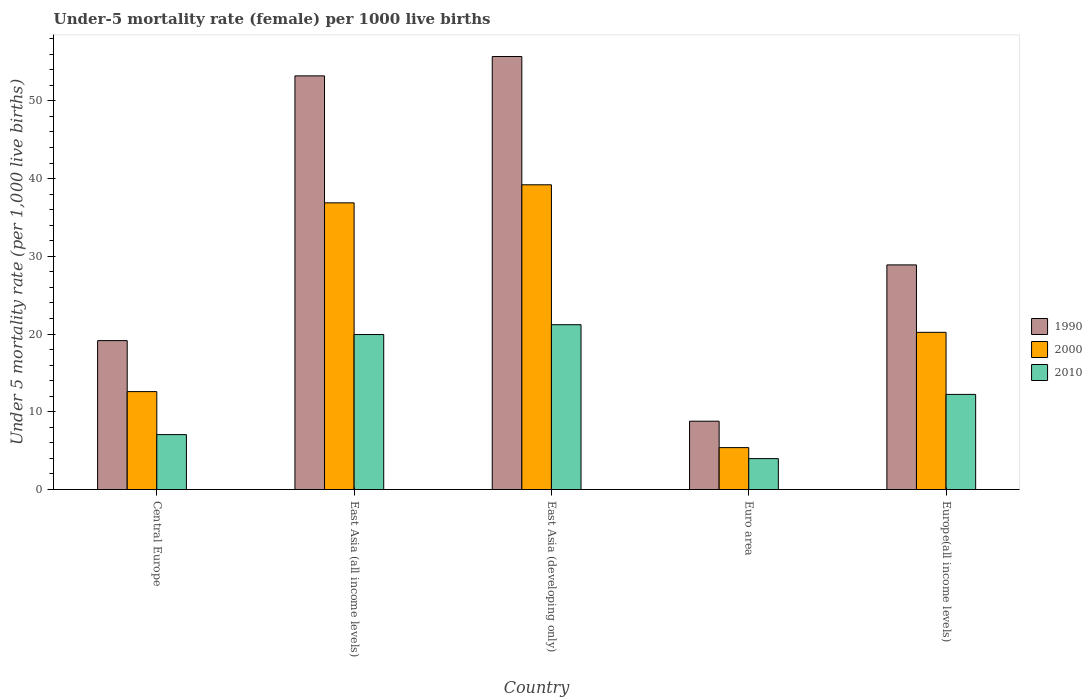How many different coloured bars are there?
Offer a very short reply. 3. Are the number of bars per tick equal to the number of legend labels?
Your answer should be compact. Yes. How many bars are there on the 1st tick from the left?
Give a very brief answer. 3. What is the label of the 5th group of bars from the left?
Provide a succinct answer. Europe(all income levels). What is the under-five mortality rate in 1990 in East Asia (all income levels)?
Your response must be concise. 53.21. Across all countries, what is the maximum under-five mortality rate in 1990?
Your answer should be very brief. 55.7. Across all countries, what is the minimum under-five mortality rate in 2010?
Your answer should be compact. 3.97. In which country was the under-five mortality rate in 1990 maximum?
Your answer should be compact. East Asia (developing only). What is the total under-five mortality rate in 1990 in the graph?
Your response must be concise. 165.75. What is the difference between the under-five mortality rate in 2000 in Euro area and that in Europe(all income levels)?
Offer a terse response. -14.83. What is the difference between the under-five mortality rate in 2000 in East Asia (all income levels) and the under-five mortality rate in 1990 in Central Europe?
Your answer should be compact. 17.73. What is the average under-five mortality rate in 2000 per country?
Your response must be concise. 22.86. What is the difference between the under-five mortality rate of/in 2010 and under-five mortality rate of/in 2000 in East Asia (all income levels)?
Make the answer very short. -16.94. In how many countries, is the under-five mortality rate in 2000 greater than 32?
Make the answer very short. 2. What is the ratio of the under-five mortality rate in 1990 in Central Europe to that in East Asia (developing only)?
Provide a short and direct response. 0.34. Is the under-five mortality rate in 1990 in East Asia (all income levels) less than that in East Asia (developing only)?
Provide a short and direct response. Yes. Is the difference between the under-five mortality rate in 2010 in Central Europe and East Asia (developing only) greater than the difference between the under-five mortality rate in 2000 in Central Europe and East Asia (developing only)?
Keep it short and to the point. Yes. What is the difference between the highest and the second highest under-five mortality rate in 1990?
Ensure brevity in your answer.  -24.32. What is the difference between the highest and the lowest under-five mortality rate in 2010?
Keep it short and to the point. 17.23. In how many countries, is the under-five mortality rate in 2010 greater than the average under-five mortality rate in 2010 taken over all countries?
Make the answer very short. 2. Is it the case that in every country, the sum of the under-five mortality rate in 2000 and under-five mortality rate in 1990 is greater than the under-five mortality rate in 2010?
Ensure brevity in your answer.  Yes. How many countries are there in the graph?
Ensure brevity in your answer.  5. What is the difference between two consecutive major ticks on the Y-axis?
Provide a short and direct response. 10. Are the values on the major ticks of Y-axis written in scientific E-notation?
Offer a very short reply. No. Does the graph contain grids?
Keep it short and to the point. No. Where does the legend appear in the graph?
Ensure brevity in your answer.  Center right. How are the legend labels stacked?
Keep it short and to the point. Vertical. What is the title of the graph?
Make the answer very short. Under-5 mortality rate (female) per 1000 live births. What is the label or title of the Y-axis?
Provide a succinct answer. Under 5 mortality rate (per 1,0 live births). What is the Under 5 mortality rate (per 1,000 live births) of 1990 in Central Europe?
Your answer should be compact. 19.15. What is the Under 5 mortality rate (per 1,000 live births) of 2000 in Central Europe?
Offer a terse response. 12.6. What is the Under 5 mortality rate (per 1,000 live births) in 2010 in Central Europe?
Offer a very short reply. 7.06. What is the Under 5 mortality rate (per 1,000 live births) of 1990 in East Asia (all income levels)?
Offer a very short reply. 53.21. What is the Under 5 mortality rate (per 1,000 live births) in 2000 in East Asia (all income levels)?
Offer a very short reply. 36.88. What is the Under 5 mortality rate (per 1,000 live births) of 2010 in East Asia (all income levels)?
Keep it short and to the point. 19.94. What is the Under 5 mortality rate (per 1,000 live births) of 1990 in East Asia (developing only)?
Keep it short and to the point. 55.7. What is the Under 5 mortality rate (per 1,000 live births) of 2000 in East Asia (developing only)?
Keep it short and to the point. 39.2. What is the Under 5 mortality rate (per 1,000 live births) of 2010 in East Asia (developing only)?
Give a very brief answer. 21.2. What is the Under 5 mortality rate (per 1,000 live births) of 1990 in Euro area?
Ensure brevity in your answer.  8.79. What is the Under 5 mortality rate (per 1,000 live births) in 2000 in Euro area?
Offer a very short reply. 5.39. What is the Under 5 mortality rate (per 1,000 live births) in 2010 in Euro area?
Offer a terse response. 3.97. What is the Under 5 mortality rate (per 1,000 live births) of 1990 in Europe(all income levels)?
Provide a succinct answer. 28.9. What is the Under 5 mortality rate (per 1,000 live births) of 2000 in Europe(all income levels)?
Provide a short and direct response. 20.22. What is the Under 5 mortality rate (per 1,000 live births) in 2010 in Europe(all income levels)?
Keep it short and to the point. 12.24. Across all countries, what is the maximum Under 5 mortality rate (per 1,000 live births) of 1990?
Provide a succinct answer. 55.7. Across all countries, what is the maximum Under 5 mortality rate (per 1,000 live births) of 2000?
Provide a succinct answer. 39.2. Across all countries, what is the maximum Under 5 mortality rate (per 1,000 live births) in 2010?
Provide a short and direct response. 21.2. Across all countries, what is the minimum Under 5 mortality rate (per 1,000 live births) in 1990?
Make the answer very short. 8.79. Across all countries, what is the minimum Under 5 mortality rate (per 1,000 live births) of 2000?
Give a very brief answer. 5.39. Across all countries, what is the minimum Under 5 mortality rate (per 1,000 live births) in 2010?
Keep it short and to the point. 3.97. What is the total Under 5 mortality rate (per 1,000 live births) of 1990 in the graph?
Offer a terse response. 165.75. What is the total Under 5 mortality rate (per 1,000 live births) in 2000 in the graph?
Offer a terse response. 114.29. What is the total Under 5 mortality rate (per 1,000 live births) in 2010 in the graph?
Ensure brevity in your answer.  64.41. What is the difference between the Under 5 mortality rate (per 1,000 live births) of 1990 in Central Europe and that in East Asia (all income levels)?
Your response must be concise. -34.06. What is the difference between the Under 5 mortality rate (per 1,000 live births) in 2000 in Central Europe and that in East Asia (all income levels)?
Offer a terse response. -24.28. What is the difference between the Under 5 mortality rate (per 1,000 live births) in 2010 in Central Europe and that in East Asia (all income levels)?
Your response must be concise. -12.87. What is the difference between the Under 5 mortality rate (per 1,000 live births) of 1990 in Central Europe and that in East Asia (developing only)?
Provide a short and direct response. -36.55. What is the difference between the Under 5 mortality rate (per 1,000 live births) of 2000 in Central Europe and that in East Asia (developing only)?
Your response must be concise. -26.6. What is the difference between the Under 5 mortality rate (per 1,000 live births) of 2010 in Central Europe and that in East Asia (developing only)?
Provide a short and direct response. -14.14. What is the difference between the Under 5 mortality rate (per 1,000 live births) in 1990 in Central Europe and that in Euro area?
Your answer should be very brief. 10.36. What is the difference between the Under 5 mortality rate (per 1,000 live births) in 2000 in Central Europe and that in Euro area?
Give a very brief answer. 7.21. What is the difference between the Under 5 mortality rate (per 1,000 live births) in 2010 in Central Europe and that in Euro area?
Your answer should be very brief. 3.09. What is the difference between the Under 5 mortality rate (per 1,000 live births) of 1990 in Central Europe and that in Europe(all income levels)?
Ensure brevity in your answer.  -9.74. What is the difference between the Under 5 mortality rate (per 1,000 live births) of 2000 in Central Europe and that in Europe(all income levels)?
Provide a short and direct response. -7.62. What is the difference between the Under 5 mortality rate (per 1,000 live births) of 2010 in Central Europe and that in Europe(all income levels)?
Provide a short and direct response. -5.17. What is the difference between the Under 5 mortality rate (per 1,000 live births) in 1990 in East Asia (all income levels) and that in East Asia (developing only)?
Provide a short and direct response. -2.49. What is the difference between the Under 5 mortality rate (per 1,000 live births) in 2000 in East Asia (all income levels) and that in East Asia (developing only)?
Make the answer very short. -2.32. What is the difference between the Under 5 mortality rate (per 1,000 live births) in 2010 in East Asia (all income levels) and that in East Asia (developing only)?
Keep it short and to the point. -1.26. What is the difference between the Under 5 mortality rate (per 1,000 live births) in 1990 in East Asia (all income levels) and that in Euro area?
Provide a short and direct response. 44.42. What is the difference between the Under 5 mortality rate (per 1,000 live births) of 2000 in East Asia (all income levels) and that in Euro area?
Your answer should be compact. 31.49. What is the difference between the Under 5 mortality rate (per 1,000 live births) in 2010 in East Asia (all income levels) and that in Euro area?
Give a very brief answer. 15.96. What is the difference between the Under 5 mortality rate (per 1,000 live births) of 1990 in East Asia (all income levels) and that in Europe(all income levels)?
Keep it short and to the point. 24.32. What is the difference between the Under 5 mortality rate (per 1,000 live births) in 2000 in East Asia (all income levels) and that in Europe(all income levels)?
Give a very brief answer. 16.66. What is the difference between the Under 5 mortality rate (per 1,000 live births) of 2010 in East Asia (all income levels) and that in Europe(all income levels)?
Your answer should be very brief. 7.7. What is the difference between the Under 5 mortality rate (per 1,000 live births) in 1990 in East Asia (developing only) and that in Euro area?
Provide a succinct answer. 46.91. What is the difference between the Under 5 mortality rate (per 1,000 live births) in 2000 in East Asia (developing only) and that in Euro area?
Your answer should be very brief. 33.81. What is the difference between the Under 5 mortality rate (per 1,000 live births) of 2010 in East Asia (developing only) and that in Euro area?
Keep it short and to the point. 17.23. What is the difference between the Under 5 mortality rate (per 1,000 live births) of 1990 in East Asia (developing only) and that in Europe(all income levels)?
Give a very brief answer. 26.8. What is the difference between the Under 5 mortality rate (per 1,000 live births) in 2000 in East Asia (developing only) and that in Europe(all income levels)?
Ensure brevity in your answer.  18.98. What is the difference between the Under 5 mortality rate (per 1,000 live births) of 2010 in East Asia (developing only) and that in Europe(all income levels)?
Keep it short and to the point. 8.96. What is the difference between the Under 5 mortality rate (per 1,000 live births) in 1990 in Euro area and that in Europe(all income levels)?
Your response must be concise. -20.11. What is the difference between the Under 5 mortality rate (per 1,000 live births) of 2000 in Euro area and that in Europe(all income levels)?
Provide a succinct answer. -14.83. What is the difference between the Under 5 mortality rate (per 1,000 live births) of 2010 in Euro area and that in Europe(all income levels)?
Provide a short and direct response. -8.26. What is the difference between the Under 5 mortality rate (per 1,000 live births) of 1990 in Central Europe and the Under 5 mortality rate (per 1,000 live births) of 2000 in East Asia (all income levels)?
Give a very brief answer. -17.73. What is the difference between the Under 5 mortality rate (per 1,000 live births) in 1990 in Central Europe and the Under 5 mortality rate (per 1,000 live births) in 2010 in East Asia (all income levels)?
Provide a short and direct response. -0.78. What is the difference between the Under 5 mortality rate (per 1,000 live births) in 2000 in Central Europe and the Under 5 mortality rate (per 1,000 live births) in 2010 in East Asia (all income levels)?
Your answer should be compact. -7.34. What is the difference between the Under 5 mortality rate (per 1,000 live births) in 1990 in Central Europe and the Under 5 mortality rate (per 1,000 live births) in 2000 in East Asia (developing only)?
Give a very brief answer. -20.05. What is the difference between the Under 5 mortality rate (per 1,000 live births) of 1990 in Central Europe and the Under 5 mortality rate (per 1,000 live births) of 2010 in East Asia (developing only)?
Ensure brevity in your answer.  -2.05. What is the difference between the Under 5 mortality rate (per 1,000 live births) in 2000 in Central Europe and the Under 5 mortality rate (per 1,000 live births) in 2010 in East Asia (developing only)?
Offer a very short reply. -8.6. What is the difference between the Under 5 mortality rate (per 1,000 live births) of 1990 in Central Europe and the Under 5 mortality rate (per 1,000 live births) of 2000 in Euro area?
Your answer should be very brief. 13.76. What is the difference between the Under 5 mortality rate (per 1,000 live births) in 1990 in Central Europe and the Under 5 mortality rate (per 1,000 live births) in 2010 in Euro area?
Provide a short and direct response. 15.18. What is the difference between the Under 5 mortality rate (per 1,000 live births) in 2000 in Central Europe and the Under 5 mortality rate (per 1,000 live births) in 2010 in Euro area?
Your answer should be very brief. 8.62. What is the difference between the Under 5 mortality rate (per 1,000 live births) in 1990 in Central Europe and the Under 5 mortality rate (per 1,000 live births) in 2000 in Europe(all income levels)?
Provide a short and direct response. -1.07. What is the difference between the Under 5 mortality rate (per 1,000 live births) in 1990 in Central Europe and the Under 5 mortality rate (per 1,000 live births) in 2010 in Europe(all income levels)?
Provide a succinct answer. 6.92. What is the difference between the Under 5 mortality rate (per 1,000 live births) of 2000 in Central Europe and the Under 5 mortality rate (per 1,000 live births) of 2010 in Europe(all income levels)?
Keep it short and to the point. 0.36. What is the difference between the Under 5 mortality rate (per 1,000 live births) in 1990 in East Asia (all income levels) and the Under 5 mortality rate (per 1,000 live births) in 2000 in East Asia (developing only)?
Provide a succinct answer. 14.01. What is the difference between the Under 5 mortality rate (per 1,000 live births) in 1990 in East Asia (all income levels) and the Under 5 mortality rate (per 1,000 live births) in 2010 in East Asia (developing only)?
Offer a very short reply. 32.01. What is the difference between the Under 5 mortality rate (per 1,000 live births) in 2000 in East Asia (all income levels) and the Under 5 mortality rate (per 1,000 live births) in 2010 in East Asia (developing only)?
Make the answer very short. 15.68. What is the difference between the Under 5 mortality rate (per 1,000 live births) of 1990 in East Asia (all income levels) and the Under 5 mortality rate (per 1,000 live births) of 2000 in Euro area?
Your answer should be very brief. 47.82. What is the difference between the Under 5 mortality rate (per 1,000 live births) in 1990 in East Asia (all income levels) and the Under 5 mortality rate (per 1,000 live births) in 2010 in Euro area?
Provide a succinct answer. 49.24. What is the difference between the Under 5 mortality rate (per 1,000 live births) of 2000 in East Asia (all income levels) and the Under 5 mortality rate (per 1,000 live births) of 2010 in Euro area?
Make the answer very short. 32.9. What is the difference between the Under 5 mortality rate (per 1,000 live births) of 1990 in East Asia (all income levels) and the Under 5 mortality rate (per 1,000 live births) of 2000 in Europe(all income levels)?
Provide a succinct answer. 32.99. What is the difference between the Under 5 mortality rate (per 1,000 live births) in 1990 in East Asia (all income levels) and the Under 5 mortality rate (per 1,000 live births) in 2010 in Europe(all income levels)?
Your response must be concise. 40.97. What is the difference between the Under 5 mortality rate (per 1,000 live births) of 2000 in East Asia (all income levels) and the Under 5 mortality rate (per 1,000 live births) of 2010 in Europe(all income levels)?
Make the answer very short. 24.64. What is the difference between the Under 5 mortality rate (per 1,000 live births) of 1990 in East Asia (developing only) and the Under 5 mortality rate (per 1,000 live births) of 2000 in Euro area?
Offer a terse response. 50.31. What is the difference between the Under 5 mortality rate (per 1,000 live births) in 1990 in East Asia (developing only) and the Under 5 mortality rate (per 1,000 live births) in 2010 in Euro area?
Your response must be concise. 51.73. What is the difference between the Under 5 mortality rate (per 1,000 live births) in 2000 in East Asia (developing only) and the Under 5 mortality rate (per 1,000 live births) in 2010 in Euro area?
Make the answer very short. 35.23. What is the difference between the Under 5 mortality rate (per 1,000 live births) in 1990 in East Asia (developing only) and the Under 5 mortality rate (per 1,000 live births) in 2000 in Europe(all income levels)?
Provide a short and direct response. 35.48. What is the difference between the Under 5 mortality rate (per 1,000 live births) of 1990 in East Asia (developing only) and the Under 5 mortality rate (per 1,000 live births) of 2010 in Europe(all income levels)?
Offer a terse response. 43.46. What is the difference between the Under 5 mortality rate (per 1,000 live births) of 2000 in East Asia (developing only) and the Under 5 mortality rate (per 1,000 live births) of 2010 in Europe(all income levels)?
Make the answer very short. 26.96. What is the difference between the Under 5 mortality rate (per 1,000 live births) in 1990 in Euro area and the Under 5 mortality rate (per 1,000 live births) in 2000 in Europe(all income levels)?
Ensure brevity in your answer.  -11.43. What is the difference between the Under 5 mortality rate (per 1,000 live births) in 1990 in Euro area and the Under 5 mortality rate (per 1,000 live births) in 2010 in Europe(all income levels)?
Your answer should be compact. -3.45. What is the difference between the Under 5 mortality rate (per 1,000 live births) of 2000 in Euro area and the Under 5 mortality rate (per 1,000 live births) of 2010 in Europe(all income levels)?
Provide a succinct answer. -6.85. What is the average Under 5 mortality rate (per 1,000 live births) of 1990 per country?
Offer a very short reply. 33.15. What is the average Under 5 mortality rate (per 1,000 live births) in 2000 per country?
Provide a short and direct response. 22.86. What is the average Under 5 mortality rate (per 1,000 live births) in 2010 per country?
Keep it short and to the point. 12.88. What is the difference between the Under 5 mortality rate (per 1,000 live births) in 1990 and Under 5 mortality rate (per 1,000 live births) in 2000 in Central Europe?
Provide a succinct answer. 6.56. What is the difference between the Under 5 mortality rate (per 1,000 live births) in 1990 and Under 5 mortality rate (per 1,000 live births) in 2010 in Central Europe?
Provide a short and direct response. 12.09. What is the difference between the Under 5 mortality rate (per 1,000 live births) in 2000 and Under 5 mortality rate (per 1,000 live births) in 2010 in Central Europe?
Provide a short and direct response. 5.53. What is the difference between the Under 5 mortality rate (per 1,000 live births) of 1990 and Under 5 mortality rate (per 1,000 live births) of 2000 in East Asia (all income levels)?
Your answer should be compact. 16.33. What is the difference between the Under 5 mortality rate (per 1,000 live births) of 1990 and Under 5 mortality rate (per 1,000 live births) of 2010 in East Asia (all income levels)?
Offer a very short reply. 33.27. What is the difference between the Under 5 mortality rate (per 1,000 live births) in 2000 and Under 5 mortality rate (per 1,000 live births) in 2010 in East Asia (all income levels)?
Ensure brevity in your answer.  16.94. What is the difference between the Under 5 mortality rate (per 1,000 live births) in 1990 and Under 5 mortality rate (per 1,000 live births) in 2000 in East Asia (developing only)?
Provide a short and direct response. 16.5. What is the difference between the Under 5 mortality rate (per 1,000 live births) of 1990 and Under 5 mortality rate (per 1,000 live births) of 2010 in East Asia (developing only)?
Give a very brief answer. 34.5. What is the difference between the Under 5 mortality rate (per 1,000 live births) of 1990 and Under 5 mortality rate (per 1,000 live births) of 2000 in Euro area?
Give a very brief answer. 3.4. What is the difference between the Under 5 mortality rate (per 1,000 live births) in 1990 and Under 5 mortality rate (per 1,000 live births) in 2010 in Euro area?
Provide a succinct answer. 4.81. What is the difference between the Under 5 mortality rate (per 1,000 live births) in 2000 and Under 5 mortality rate (per 1,000 live births) in 2010 in Euro area?
Your answer should be very brief. 1.42. What is the difference between the Under 5 mortality rate (per 1,000 live births) of 1990 and Under 5 mortality rate (per 1,000 live births) of 2000 in Europe(all income levels)?
Your response must be concise. 8.68. What is the difference between the Under 5 mortality rate (per 1,000 live births) in 1990 and Under 5 mortality rate (per 1,000 live births) in 2010 in Europe(all income levels)?
Provide a short and direct response. 16.66. What is the difference between the Under 5 mortality rate (per 1,000 live births) in 2000 and Under 5 mortality rate (per 1,000 live births) in 2010 in Europe(all income levels)?
Your answer should be compact. 7.98. What is the ratio of the Under 5 mortality rate (per 1,000 live births) in 1990 in Central Europe to that in East Asia (all income levels)?
Your answer should be very brief. 0.36. What is the ratio of the Under 5 mortality rate (per 1,000 live births) in 2000 in Central Europe to that in East Asia (all income levels)?
Offer a very short reply. 0.34. What is the ratio of the Under 5 mortality rate (per 1,000 live births) of 2010 in Central Europe to that in East Asia (all income levels)?
Offer a terse response. 0.35. What is the ratio of the Under 5 mortality rate (per 1,000 live births) in 1990 in Central Europe to that in East Asia (developing only)?
Your answer should be compact. 0.34. What is the ratio of the Under 5 mortality rate (per 1,000 live births) of 2000 in Central Europe to that in East Asia (developing only)?
Your answer should be very brief. 0.32. What is the ratio of the Under 5 mortality rate (per 1,000 live births) in 2010 in Central Europe to that in East Asia (developing only)?
Offer a very short reply. 0.33. What is the ratio of the Under 5 mortality rate (per 1,000 live births) in 1990 in Central Europe to that in Euro area?
Make the answer very short. 2.18. What is the ratio of the Under 5 mortality rate (per 1,000 live births) of 2000 in Central Europe to that in Euro area?
Your answer should be compact. 2.34. What is the ratio of the Under 5 mortality rate (per 1,000 live births) in 2010 in Central Europe to that in Euro area?
Keep it short and to the point. 1.78. What is the ratio of the Under 5 mortality rate (per 1,000 live births) of 1990 in Central Europe to that in Europe(all income levels)?
Offer a very short reply. 0.66. What is the ratio of the Under 5 mortality rate (per 1,000 live births) in 2000 in Central Europe to that in Europe(all income levels)?
Offer a terse response. 0.62. What is the ratio of the Under 5 mortality rate (per 1,000 live births) in 2010 in Central Europe to that in Europe(all income levels)?
Ensure brevity in your answer.  0.58. What is the ratio of the Under 5 mortality rate (per 1,000 live births) in 1990 in East Asia (all income levels) to that in East Asia (developing only)?
Ensure brevity in your answer.  0.96. What is the ratio of the Under 5 mortality rate (per 1,000 live births) of 2000 in East Asia (all income levels) to that in East Asia (developing only)?
Your response must be concise. 0.94. What is the ratio of the Under 5 mortality rate (per 1,000 live births) of 2010 in East Asia (all income levels) to that in East Asia (developing only)?
Make the answer very short. 0.94. What is the ratio of the Under 5 mortality rate (per 1,000 live births) of 1990 in East Asia (all income levels) to that in Euro area?
Make the answer very short. 6.05. What is the ratio of the Under 5 mortality rate (per 1,000 live births) of 2000 in East Asia (all income levels) to that in Euro area?
Provide a succinct answer. 6.84. What is the ratio of the Under 5 mortality rate (per 1,000 live births) of 2010 in East Asia (all income levels) to that in Euro area?
Offer a very short reply. 5.02. What is the ratio of the Under 5 mortality rate (per 1,000 live births) of 1990 in East Asia (all income levels) to that in Europe(all income levels)?
Your response must be concise. 1.84. What is the ratio of the Under 5 mortality rate (per 1,000 live births) in 2000 in East Asia (all income levels) to that in Europe(all income levels)?
Your answer should be very brief. 1.82. What is the ratio of the Under 5 mortality rate (per 1,000 live births) in 2010 in East Asia (all income levels) to that in Europe(all income levels)?
Offer a very short reply. 1.63. What is the ratio of the Under 5 mortality rate (per 1,000 live births) in 1990 in East Asia (developing only) to that in Euro area?
Keep it short and to the point. 6.34. What is the ratio of the Under 5 mortality rate (per 1,000 live births) in 2000 in East Asia (developing only) to that in Euro area?
Give a very brief answer. 7.27. What is the ratio of the Under 5 mortality rate (per 1,000 live births) in 2010 in East Asia (developing only) to that in Euro area?
Provide a short and direct response. 5.33. What is the ratio of the Under 5 mortality rate (per 1,000 live births) of 1990 in East Asia (developing only) to that in Europe(all income levels)?
Your answer should be very brief. 1.93. What is the ratio of the Under 5 mortality rate (per 1,000 live births) of 2000 in East Asia (developing only) to that in Europe(all income levels)?
Your answer should be very brief. 1.94. What is the ratio of the Under 5 mortality rate (per 1,000 live births) of 2010 in East Asia (developing only) to that in Europe(all income levels)?
Give a very brief answer. 1.73. What is the ratio of the Under 5 mortality rate (per 1,000 live births) of 1990 in Euro area to that in Europe(all income levels)?
Your answer should be very brief. 0.3. What is the ratio of the Under 5 mortality rate (per 1,000 live births) of 2000 in Euro area to that in Europe(all income levels)?
Your answer should be compact. 0.27. What is the ratio of the Under 5 mortality rate (per 1,000 live births) in 2010 in Euro area to that in Europe(all income levels)?
Ensure brevity in your answer.  0.32. What is the difference between the highest and the second highest Under 5 mortality rate (per 1,000 live births) of 1990?
Make the answer very short. 2.49. What is the difference between the highest and the second highest Under 5 mortality rate (per 1,000 live births) in 2000?
Your answer should be compact. 2.32. What is the difference between the highest and the second highest Under 5 mortality rate (per 1,000 live births) of 2010?
Offer a very short reply. 1.26. What is the difference between the highest and the lowest Under 5 mortality rate (per 1,000 live births) in 1990?
Your answer should be compact. 46.91. What is the difference between the highest and the lowest Under 5 mortality rate (per 1,000 live births) in 2000?
Your answer should be very brief. 33.81. What is the difference between the highest and the lowest Under 5 mortality rate (per 1,000 live births) of 2010?
Make the answer very short. 17.23. 